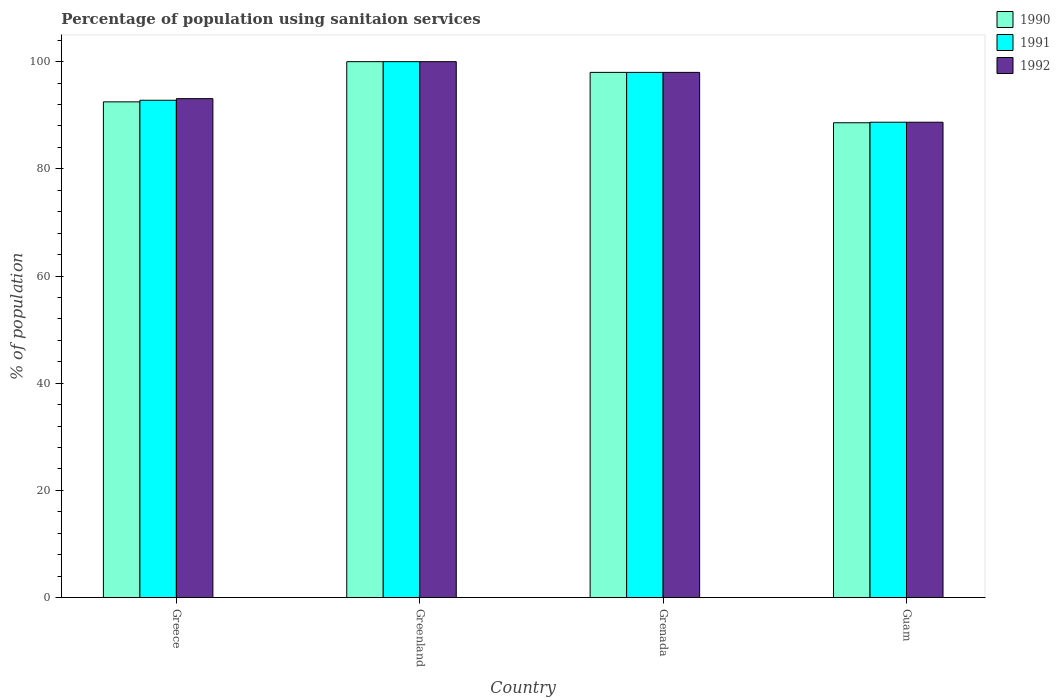How many groups of bars are there?
Keep it short and to the point. 4. Are the number of bars per tick equal to the number of legend labels?
Offer a very short reply. Yes. What is the label of the 3rd group of bars from the left?
Your answer should be very brief. Grenada. What is the percentage of population using sanitaion services in 1992 in Guam?
Offer a very short reply. 88.7. Across all countries, what is the maximum percentage of population using sanitaion services in 1991?
Give a very brief answer. 100. Across all countries, what is the minimum percentage of population using sanitaion services in 1991?
Offer a terse response. 88.7. In which country was the percentage of population using sanitaion services in 1990 maximum?
Give a very brief answer. Greenland. In which country was the percentage of population using sanitaion services in 1990 minimum?
Your response must be concise. Guam. What is the total percentage of population using sanitaion services in 1991 in the graph?
Keep it short and to the point. 379.5. What is the difference between the percentage of population using sanitaion services in 1992 in Greece and that in Greenland?
Provide a succinct answer. -6.9. What is the difference between the percentage of population using sanitaion services in 1992 in Guam and the percentage of population using sanitaion services in 1990 in Greenland?
Your answer should be very brief. -11.3. What is the average percentage of population using sanitaion services in 1992 per country?
Make the answer very short. 94.95. What is the difference between the percentage of population using sanitaion services of/in 1991 and percentage of population using sanitaion services of/in 1990 in Guam?
Keep it short and to the point. 0.1. In how many countries, is the percentage of population using sanitaion services in 1991 greater than 32 %?
Provide a succinct answer. 4. What is the ratio of the percentage of population using sanitaion services in 1990 in Greece to that in Greenland?
Your answer should be very brief. 0.93. Is the percentage of population using sanitaion services in 1992 in Greece less than that in Greenland?
Keep it short and to the point. Yes. Is the difference between the percentage of population using sanitaion services in 1991 in Greece and Grenada greater than the difference between the percentage of population using sanitaion services in 1990 in Greece and Grenada?
Keep it short and to the point. Yes. What is the difference between the highest and the lowest percentage of population using sanitaion services in 1991?
Provide a short and direct response. 11.3. In how many countries, is the percentage of population using sanitaion services in 1992 greater than the average percentage of population using sanitaion services in 1992 taken over all countries?
Provide a succinct answer. 2. Is the sum of the percentage of population using sanitaion services in 1992 in Greenland and Grenada greater than the maximum percentage of population using sanitaion services in 1991 across all countries?
Ensure brevity in your answer.  Yes. How many bars are there?
Give a very brief answer. 12. How many countries are there in the graph?
Your response must be concise. 4. What is the difference between two consecutive major ticks on the Y-axis?
Your answer should be very brief. 20. Are the values on the major ticks of Y-axis written in scientific E-notation?
Your answer should be very brief. No. Does the graph contain any zero values?
Offer a very short reply. No. Where does the legend appear in the graph?
Offer a very short reply. Top right. How are the legend labels stacked?
Your response must be concise. Vertical. What is the title of the graph?
Make the answer very short. Percentage of population using sanitaion services. Does "2012" appear as one of the legend labels in the graph?
Provide a short and direct response. No. What is the label or title of the Y-axis?
Make the answer very short. % of population. What is the % of population in 1990 in Greece?
Give a very brief answer. 92.5. What is the % of population of 1991 in Greece?
Provide a succinct answer. 92.8. What is the % of population in 1992 in Greece?
Keep it short and to the point. 93.1. What is the % of population of 1990 in Greenland?
Provide a succinct answer. 100. What is the % of population of 1992 in Greenland?
Your answer should be very brief. 100. What is the % of population in 1990 in Grenada?
Provide a succinct answer. 98. What is the % of population of 1992 in Grenada?
Your response must be concise. 98. What is the % of population in 1990 in Guam?
Offer a terse response. 88.6. What is the % of population of 1991 in Guam?
Provide a short and direct response. 88.7. What is the % of population in 1992 in Guam?
Make the answer very short. 88.7. Across all countries, what is the maximum % of population in 1992?
Keep it short and to the point. 100. Across all countries, what is the minimum % of population of 1990?
Provide a succinct answer. 88.6. Across all countries, what is the minimum % of population in 1991?
Your answer should be very brief. 88.7. Across all countries, what is the minimum % of population of 1992?
Give a very brief answer. 88.7. What is the total % of population in 1990 in the graph?
Offer a terse response. 379.1. What is the total % of population in 1991 in the graph?
Give a very brief answer. 379.5. What is the total % of population in 1992 in the graph?
Keep it short and to the point. 379.8. What is the difference between the % of population of 1991 in Greece and that in Greenland?
Make the answer very short. -7.2. What is the difference between the % of population of 1992 in Greece and that in Greenland?
Make the answer very short. -6.9. What is the difference between the % of population in 1991 in Greece and that in Grenada?
Ensure brevity in your answer.  -5.2. What is the difference between the % of population in 1990 in Greece and that in Guam?
Provide a short and direct response. 3.9. What is the difference between the % of population in 1992 in Greece and that in Guam?
Give a very brief answer. 4.4. What is the difference between the % of population in 1990 in Greenland and that in Grenada?
Provide a succinct answer. 2. What is the difference between the % of population of 1992 in Greenland and that in Grenada?
Your answer should be compact. 2. What is the difference between the % of population in 1991 in Greenland and that in Guam?
Provide a short and direct response. 11.3. What is the difference between the % of population in 1992 in Greenland and that in Guam?
Keep it short and to the point. 11.3. What is the difference between the % of population of 1991 in Grenada and that in Guam?
Provide a short and direct response. 9.3. What is the difference between the % of population in 1990 in Greece and the % of population in 1991 in Greenland?
Give a very brief answer. -7.5. What is the difference between the % of population in 1990 in Greece and the % of population in 1992 in Greenland?
Your answer should be compact. -7.5. What is the difference between the % of population in 1991 in Greece and the % of population in 1992 in Grenada?
Keep it short and to the point. -5.2. What is the difference between the % of population of 1990 in Greece and the % of population of 1992 in Guam?
Provide a short and direct response. 3.8. What is the difference between the % of population of 1991 in Greece and the % of population of 1992 in Guam?
Offer a terse response. 4.1. What is the difference between the % of population of 1990 in Greenland and the % of population of 1991 in Grenada?
Your answer should be very brief. 2. What is the difference between the % of population of 1990 in Greenland and the % of population of 1992 in Grenada?
Offer a very short reply. 2. What is the difference between the % of population in 1991 in Greenland and the % of population in 1992 in Grenada?
Provide a short and direct response. 2. What is the difference between the % of population of 1990 in Greenland and the % of population of 1992 in Guam?
Keep it short and to the point. 11.3. What is the average % of population of 1990 per country?
Provide a succinct answer. 94.78. What is the average % of population of 1991 per country?
Offer a very short reply. 94.88. What is the average % of population of 1992 per country?
Provide a short and direct response. 94.95. What is the difference between the % of population of 1990 and % of population of 1991 in Greece?
Give a very brief answer. -0.3. What is the difference between the % of population of 1990 and % of population of 1992 in Greenland?
Offer a very short reply. 0. What is the difference between the % of population in 1991 and % of population in 1992 in Greenland?
Keep it short and to the point. 0. What is the difference between the % of population in 1990 and % of population in 1991 in Grenada?
Your answer should be very brief. 0. What is the difference between the % of population in 1991 and % of population in 1992 in Grenada?
Your answer should be very brief. 0. What is the difference between the % of population in 1990 and % of population in 1992 in Guam?
Ensure brevity in your answer.  -0.1. What is the difference between the % of population of 1991 and % of population of 1992 in Guam?
Your answer should be compact. 0. What is the ratio of the % of population in 1990 in Greece to that in Greenland?
Provide a short and direct response. 0.93. What is the ratio of the % of population in 1991 in Greece to that in Greenland?
Give a very brief answer. 0.93. What is the ratio of the % of population of 1990 in Greece to that in Grenada?
Offer a very short reply. 0.94. What is the ratio of the % of population in 1991 in Greece to that in Grenada?
Your answer should be very brief. 0.95. What is the ratio of the % of population of 1990 in Greece to that in Guam?
Give a very brief answer. 1.04. What is the ratio of the % of population in 1991 in Greece to that in Guam?
Your answer should be very brief. 1.05. What is the ratio of the % of population of 1992 in Greece to that in Guam?
Offer a terse response. 1.05. What is the ratio of the % of population in 1990 in Greenland to that in Grenada?
Give a very brief answer. 1.02. What is the ratio of the % of population of 1991 in Greenland to that in Grenada?
Offer a terse response. 1.02. What is the ratio of the % of population in 1992 in Greenland to that in Grenada?
Your response must be concise. 1.02. What is the ratio of the % of population of 1990 in Greenland to that in Guam?
Offer a terse response. 1.13. What is the ratio of the % of population of 1991 in Greenland to that in Guam?
Offer a very short reply. 1.13. What is the ratio of the % of population in 1992 in Greenland to that in Guam?
Make the answer very short. 1.13. What is the ratio of the % of population of 1990 in Grenada to that in Guam?
Your response must be concise. 1.11. What is the ratio of the % of population of 1991 in Grenada to that in Guam?
Give a very brief answer. 1.1. What is the ratio of the % of population in 1992 in Grenada to that in Guam?
Provide a short and direct response. 1.1. What is the difference between the highest and the second highest % of population of 1992?
Make the answer very short. 2. What is the difference between the highest and the lowest % of population of 1990?
Provide a succinct answer. 11.4. What is the difference between the highest and the lowest % of population in 1991?
Make the answer very short. 11.3. 